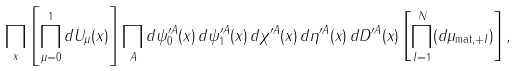Convert formula to latex. <formula><loc_0><loc_0><loc_500><loc_500>\prod _ { x } \left [ \prod _ { \mu = 0 } ^ { 1 } d U _ { \mu } ( x ) \right ] \prod _ { A } d \psi _ { 0 } ^ { \prime A } ( x ) \, d \psi _ { 1 } ^ { \prime A } ( x ) \, d \chi ^ { \prime A } ( x ) \, d \eta ^ { \prime A } ( x ) \, d D ^ { \prime A } ( x ) \left [ \prod _ { I = 1 } ^ { N } ( d \mu _ { \text {mat} , + I } ) \right ] ,</formula> 